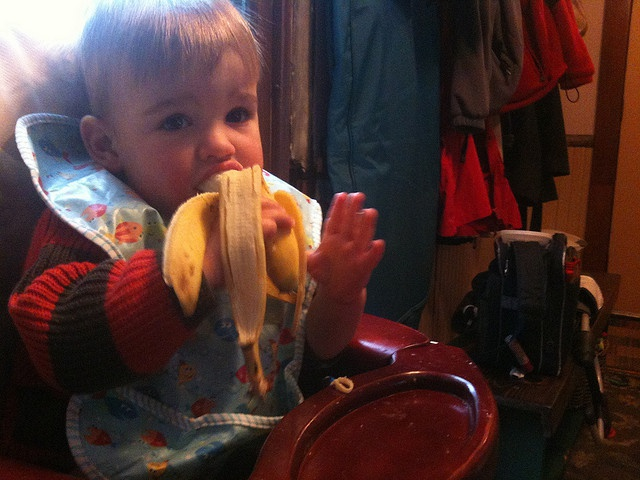Describe the objects in this image and their specific colors. I can see people in ivory, black, maroon, purple, and brown tones, handbag in ivory, black, darkblue, maroon, and brown tones, people in ivory, black, gray, and maroon tones, banana in ivory, orange, brown, and maroon tones, and handbag in ivory, black, maroon, and brown tones in this image. 